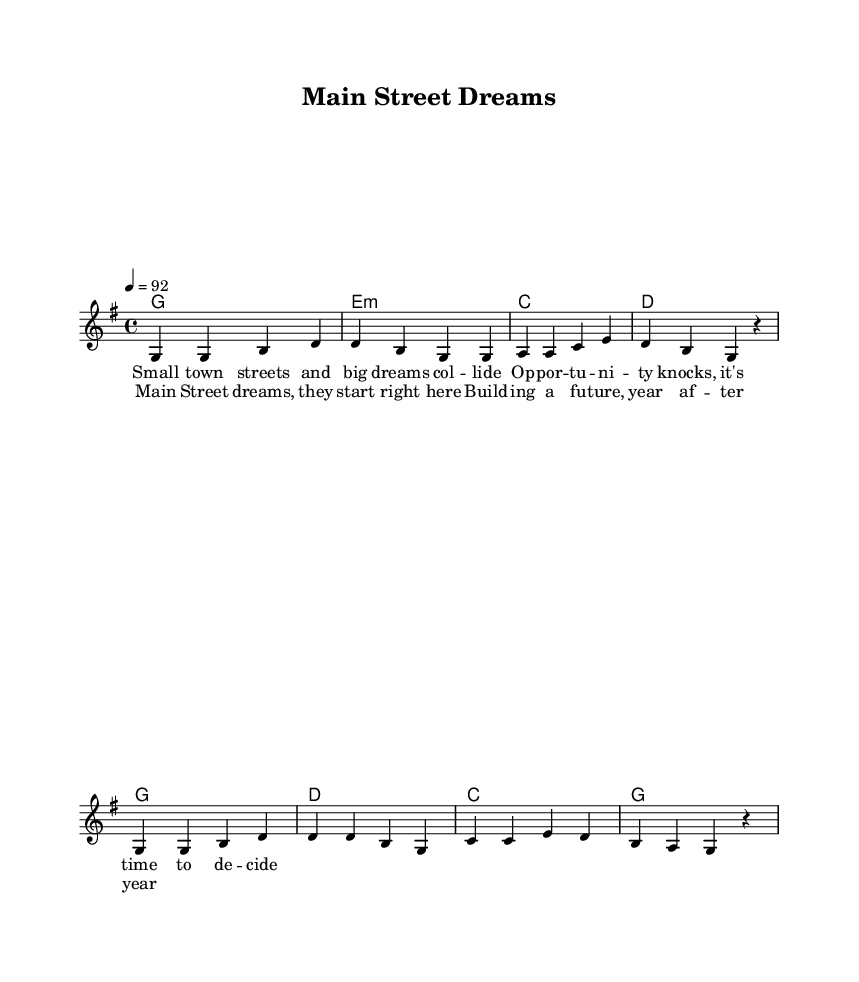What is the key signature of this music? The key signature shown at the beginning of the score indicates G major, which has one sharp (F#).
Answer: G major What is the time signature of this music? The time signature displayed at the beginning is 4/4, indicating four beats per measure.
Answer: 4/4 What is the tempo indication for this piece? The tempo marking states "4 = 92," meaning there are 92 beats per minute.
Answer: 92 How many measures are in the verse? By counting the groups of notes in the verse section of the melody, we see there are four measures.
Answer: 4 How many chords are used in the chorus? The chord section for the chorus includes four different chords: G, D, C, and G again.
Answer: 4 What thematic elements does this song explore? Analyzing the lyrics and title, the song explores themes of small town entrepreneurship and building dreams in a local community.
Answer: Small town entrepreneurship What is the overall structure of the song? The song consists of a verse followed by a chorus, indicating a verse-chorus format commonly used in contemporary music.
Answer: Verse-Chorus 